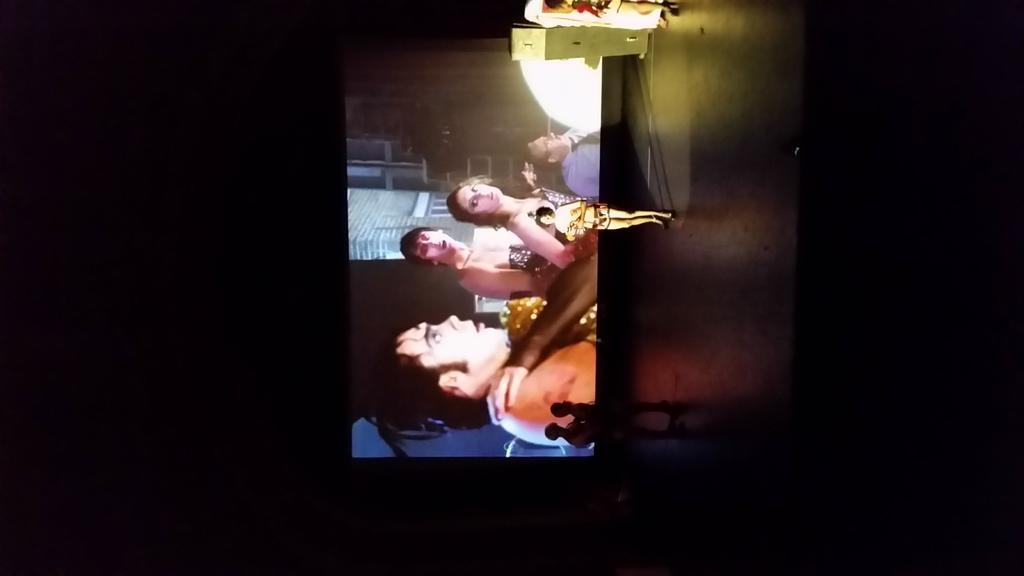Can you describe this image briefly? In this picture we can see three people standing on a stage and in the background we can see a screen and on the screen we can see some people. 